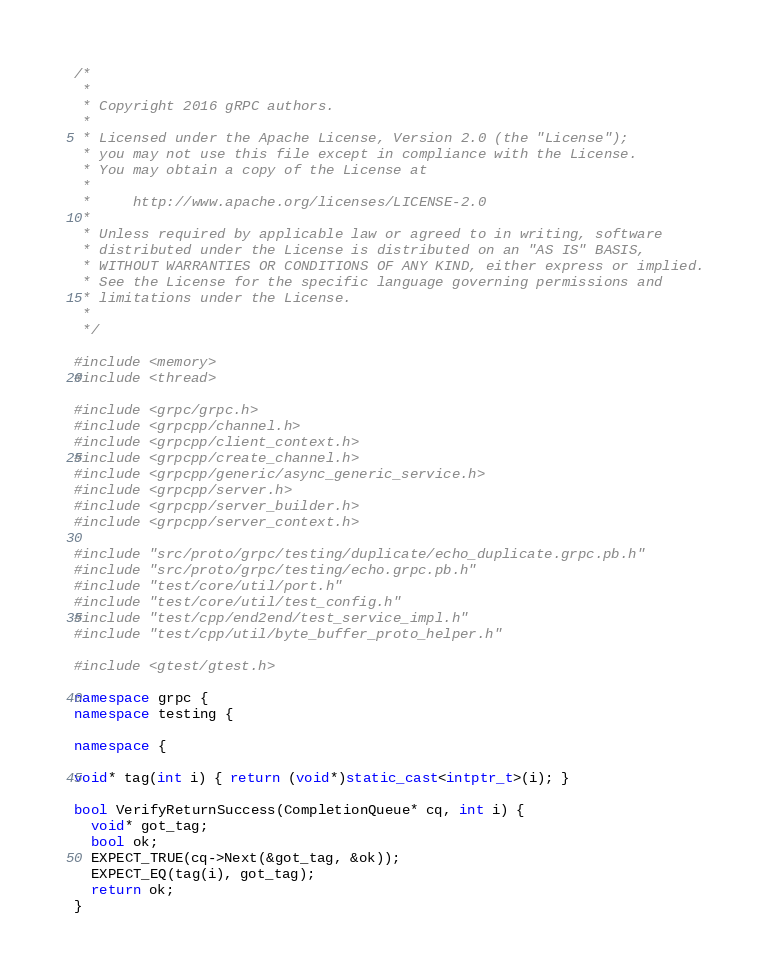Convert code to text. <code><loc_0><loc_0><loc_500><loc_500><_C++_>/*
 *
 * Copyright 2016 gRPC authors.
 *
 * Licensed under the Apache License, Version 2.0 (the "License");
 * you may not use this file except in compliance with the License.
 * You may obtain a copy of the License at
 *
 *     http://www.apache.org/licenses/LICENSE-2.0
 *
 * Unless required by applicable law or agreed to in writing, software
 * distributed under the License is distributed on an "AS IS" BASIS,
 * WITHOUT WARRANTIES OR CONDITIONS OF ANY KIND, either express or implied.
 * See the License for the specific language governing permissions and
 * limitations under the License.
 *
 */

#include <memory>
#include <thread>

#include <grpc/grpc.h>
#include <grpcpp/channel.h>
#include <grpcpp/client_context.h>
#include <grpcpp/create_channel.h>
#include <grpcpp/generic/async_generic_service.h>
#include <grpcpp/server.h>
#include <grpcpp/server_builder.h>
#include <grpcpp/server_context.h>

#include "src/proto/grpc/testing/duplicate/echo_duplicate.grpc.pb.h"
#include "src/proto/grpc/testing/echo.grpc.pb.h"
#include "test/core/util/port.h"
#include "test/core/util/test_config.h"
#include "test/cpp/end2end/test_service_impl.h"
#include "test/cpp/util/byte_buffer_proto_helper.h"

#include <gtest/gtest.h>

namespace grpc {
namespace testing {

namespace {

void* tag(int i) { return (void*)static_cast<intptr_t>(i); }

bool VerifyReturnSuccess(CompletionQueue* cq, int i) {
  void* got_tag;
  bool ok;
  EXPECT_TRUE(cq->Next(&got_tag, &ok));
  EXPECT_EQ(tag(i), got_tag);
  return ok;
}
</code> 